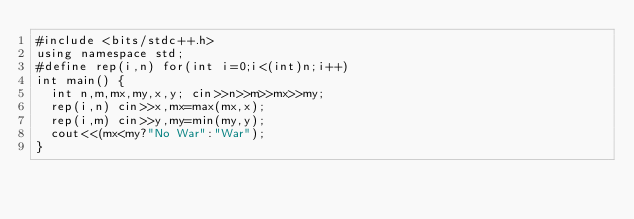<code> <loc_0><loc_0><loc_500><loc_500><_C++_>#include <bits/stdc++.h>
using namespace std;
#define rep(i,n) for(int i=0;i<(int)n;i++)
int main() {
  int n,m,mx,my,x,y; cin>>n>>m>>mx>>my;
  rep(i,n) cin>>x,mx=max(mx,x);
  rep(i,m) cin>>y,my=min(my,y);
  cout<<(mx<my?"No War":"War");
}</code> 